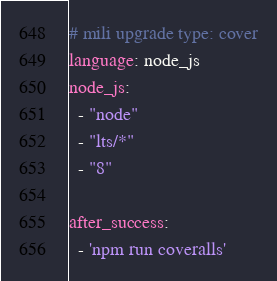<code> <loc_0><loc_0><loc_500><loc_500><_YAML_># mili upgrade type: cover
language: node_js
node_js:
  - "node"
  - "lts/*"
  - "8"

after_success:
  - 'npm run coveralls'
</code> 